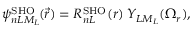<formula> <loc_0><loc_0><loc_500><loc_500>\psi _ { n L M _ { L } } ^ { S H O } \, ( \vec { r } ) = R _ { n L } ^ { S H O } ( r ) \, Y _ { L M _ { L } } ( \Omega _ { r } ) ,</formula> 